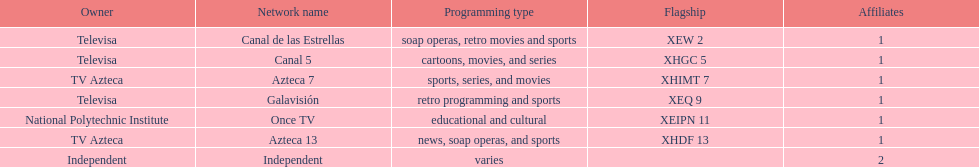What is the average number of affiliates that a given network will have? 1. 